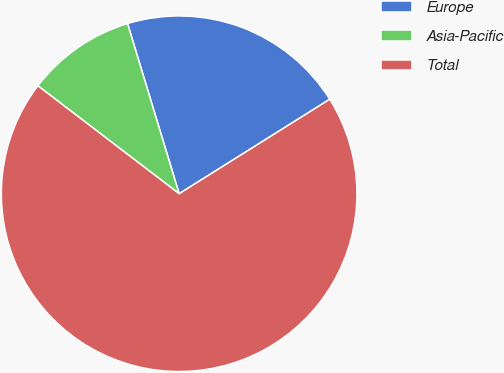<chart> <loc_0><loc_0><loc_500><loc_500><pie_chart><fcel>Europe<fcel>Asia-Pacific<fcel>Total<nl><fcel>20.77%<fcel>9.93%<fcel>69.3%<nl></chart> 